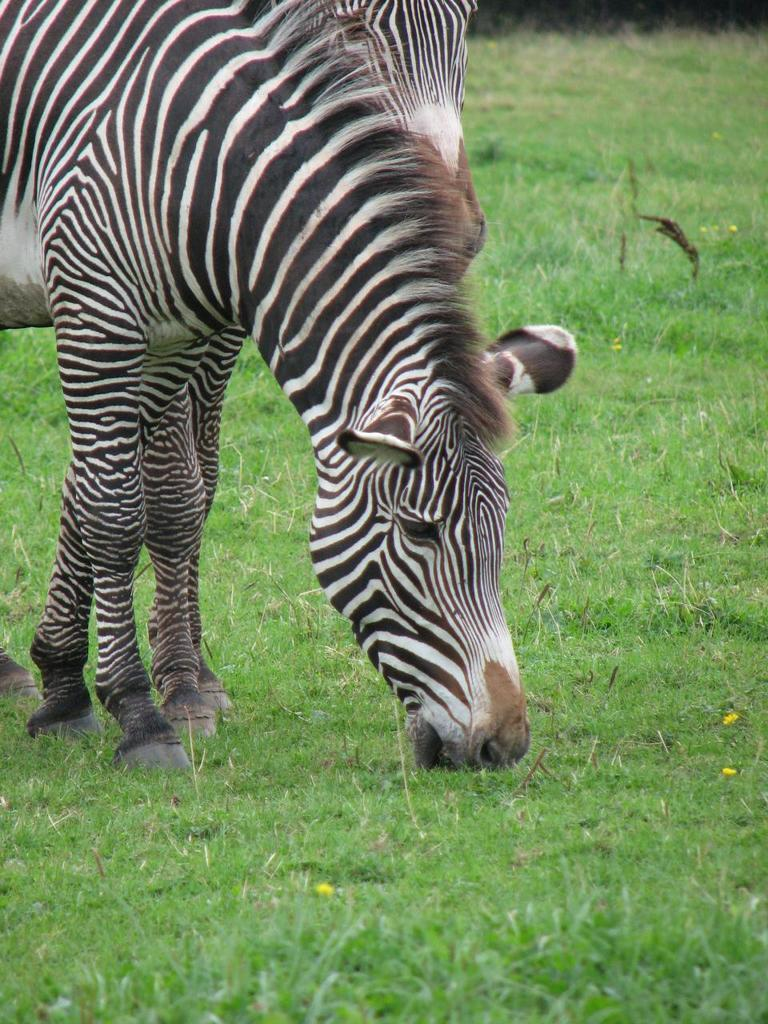What animal is the main subject of the image? There is a zebra in the image. What is the zebra standing on in the image? The zebra is on the surface of the grass. What team is the zebra a part of in the image? There is no team present in the image, as it features a zebra standing on grass. 